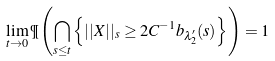Convert formula to latex. <formula><loc_0><loc_0><loc_500><loc_500>\lim _ { t \to 0 } \P \left ( \bigcap _ { s \leq t } \left \{ | | X | | _ { s } \geq 2 C ^ { - 1 } b _ { \lambda _ { 2 } ^ { \prime } } ( s ) \right \} \right ) = 1</formula> 